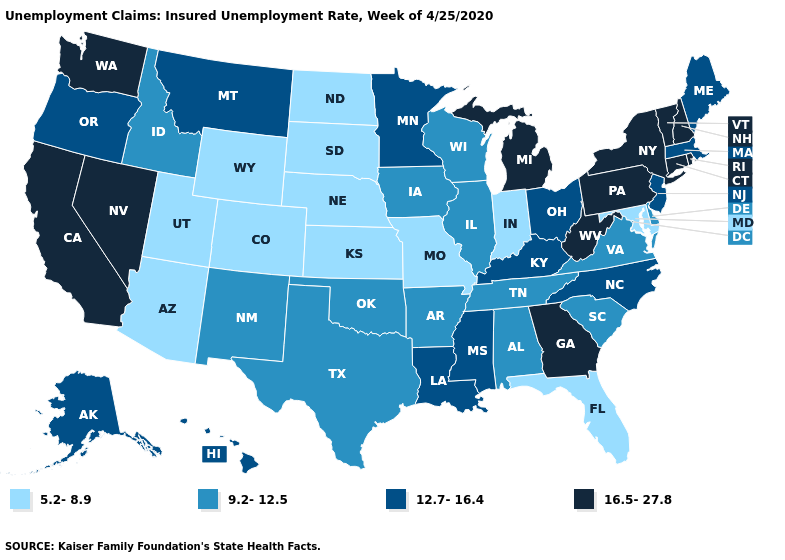Does Virginia have a lower value than Texas?
Give a very brief answer. No. How many symbols are there in the legend?
Give a very brief answer. 4. Among the states that border Iowa , which have the highest value?
Short answer required. Minnesota. What is the value of Rhode Island?
Answer briefly. 16.5-27.8. What is the highest value in states that border Mississippi?
Keep it brief. 12.7-16.4. What is the highest value in the USA?
Write a very short answer. 16.5-27.8. What is the value of Hawaii?
Answer briefly. 12.7-16.4. Among the states that border Oregon , does Idaho have the highest value?
Answer briefly. No. What is the value of Mississippi?
Quick response, please. 12.7-16.4. Does Wisconsin have a lower value than Tennessee?
Short answer required. No. Name the states that have a value in the range 12.7-16.4?
Be succinct. Alaska, Hawaii, Kentucky, Louisiana, Maine, Massachusetts, Minnesota, Mississippi, Montana, New Jersey, North Carolina, Ohio, Oregon. Name the states that have a value in the range 5.2-8.9?
Be succinct. Arizona, Colorado, Florida, Indiana, Kansas, Maryland, Missouri, Nebraska, North Dakota, South Dakota, Utah, Wyoming. Name the states that have a value in the range 5.2-8.9?
Short answer required. Arizona, Colorado, Florida, Indiana, Kansas, Maryland, Missouri, Nebraska, North Dakota, South Dakota, Utah, Wyoming. Does New Mexico have the lowest value in the West?
Be succinct. No. Name the states that have a value in the range 12.7-16.4?
Concise answer only. Alaska, Hawaii, Kentucky, Louisiana, Maine, Massachusetts, Minnesota, Mississippi, Montana, New Jersey, North Carolina, Ohio, Oregon. 